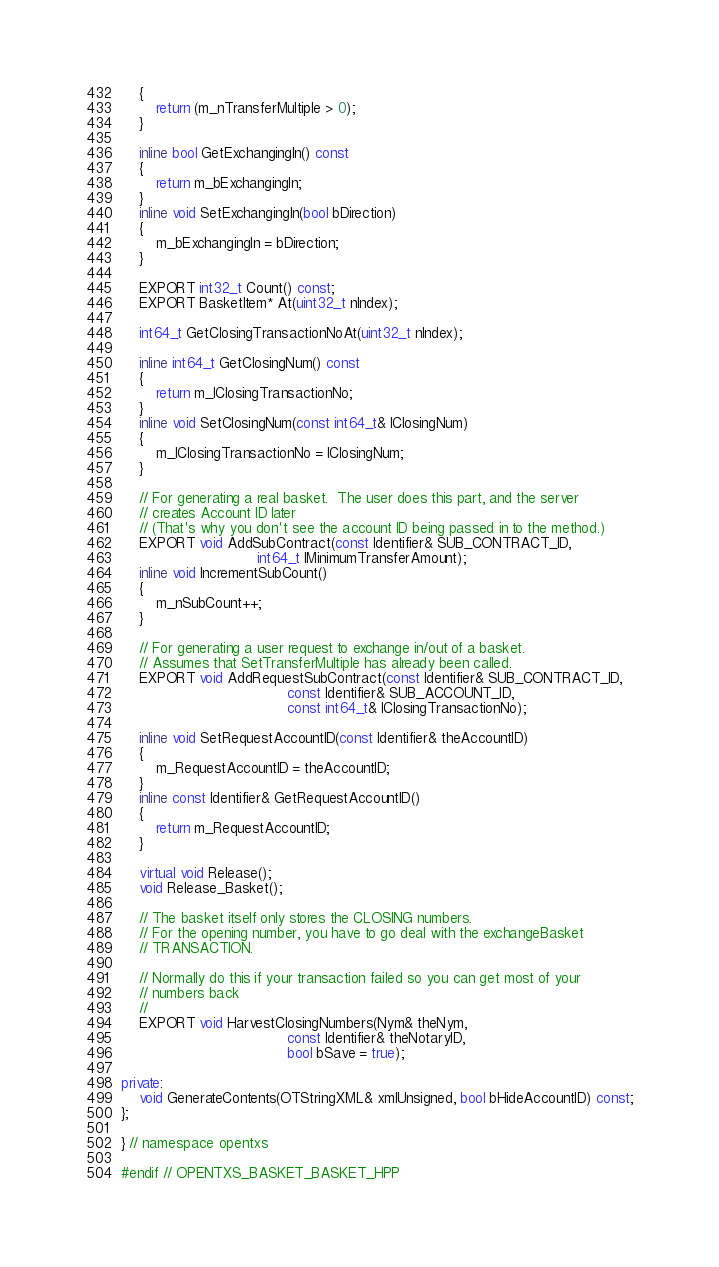Convert code to text. <code><loc_0><loc_0><loc_500><loc_500><_C++_>    {
        return (m_nTransferMultiple > 0);
    }

    inline bool GetExchangingIn() const
    {
        return m_bExchangingIn;
    }
    inline void SetExchangingIn(bool bDirection)
    {
        m_bExchangingIn = bDirection;
    }

    EXPORT int32_t Count() const;
    EXPORT BasketItem* At(uint32_t nIndex);

    int64_t GetClosingTransactionNoAt(uint32_t nIndex);

    inline int64_t GetClosingNum() const
    {
        return m_lClosingTransactionNo;
    }
    inline void SetClosingNum(const int64_t& lClosingNum)
    {
        m_lClosingTransactionNo = lClosingNum;
    }

    // For generating a real basket.  The user does this part, and the server
    // creates Account ID later
    // (That's why you don't see the account ID being passed in to the method.)
    EXPORT void AddSubContract(const Identifier& SUB_CONTRACT_ID,
                               int64_t lMinimumTransferAmount);
    inline void IncrementSubCount()
    {
        m_nSubCount++;
    }

    // For generating a user request to exchange in/out of a basket.
    // Assumes that SetTransferMultiple has already been called.
    EXPORT void AddRequestSubContract(const Identifier& SUB_CONTRACT_ID,
                                      const Identifier& SUB_ACCOUNT_ID,
                                      const int64_t& lClosingTransactionNo);

    inline void SetRequestAccountID(const Identifier& theAccountID)
    {
        m_RequestAccountID = theAccountID;
    }
    inline const Identifier& GetRequestAccountID()
    {
        return m_RequestAccountID;
    }

    virtual void Release();
    void Release_Basket();

    // The basket itself only stores the CLOSING numbers.
    // For the opening number, you have to go deal with the exchangeBasket
    // TRANSACTION.

    // Normally do this if your transaction failed so you can get most of your
    // numbers back
    //
    EXPORT void HarvestClosingNumbers(Nym& theNym,
                                      const Identifier& theNotaryID,
                                      bool bSave = true);

private:
    void GenerateContents(OTStringXML& xmlUnsigned, bool bHideAccountID) const;
};

} // namespace opentxs

#endif // OPENTXS_BASKET_BASKET_HPP
</code> 